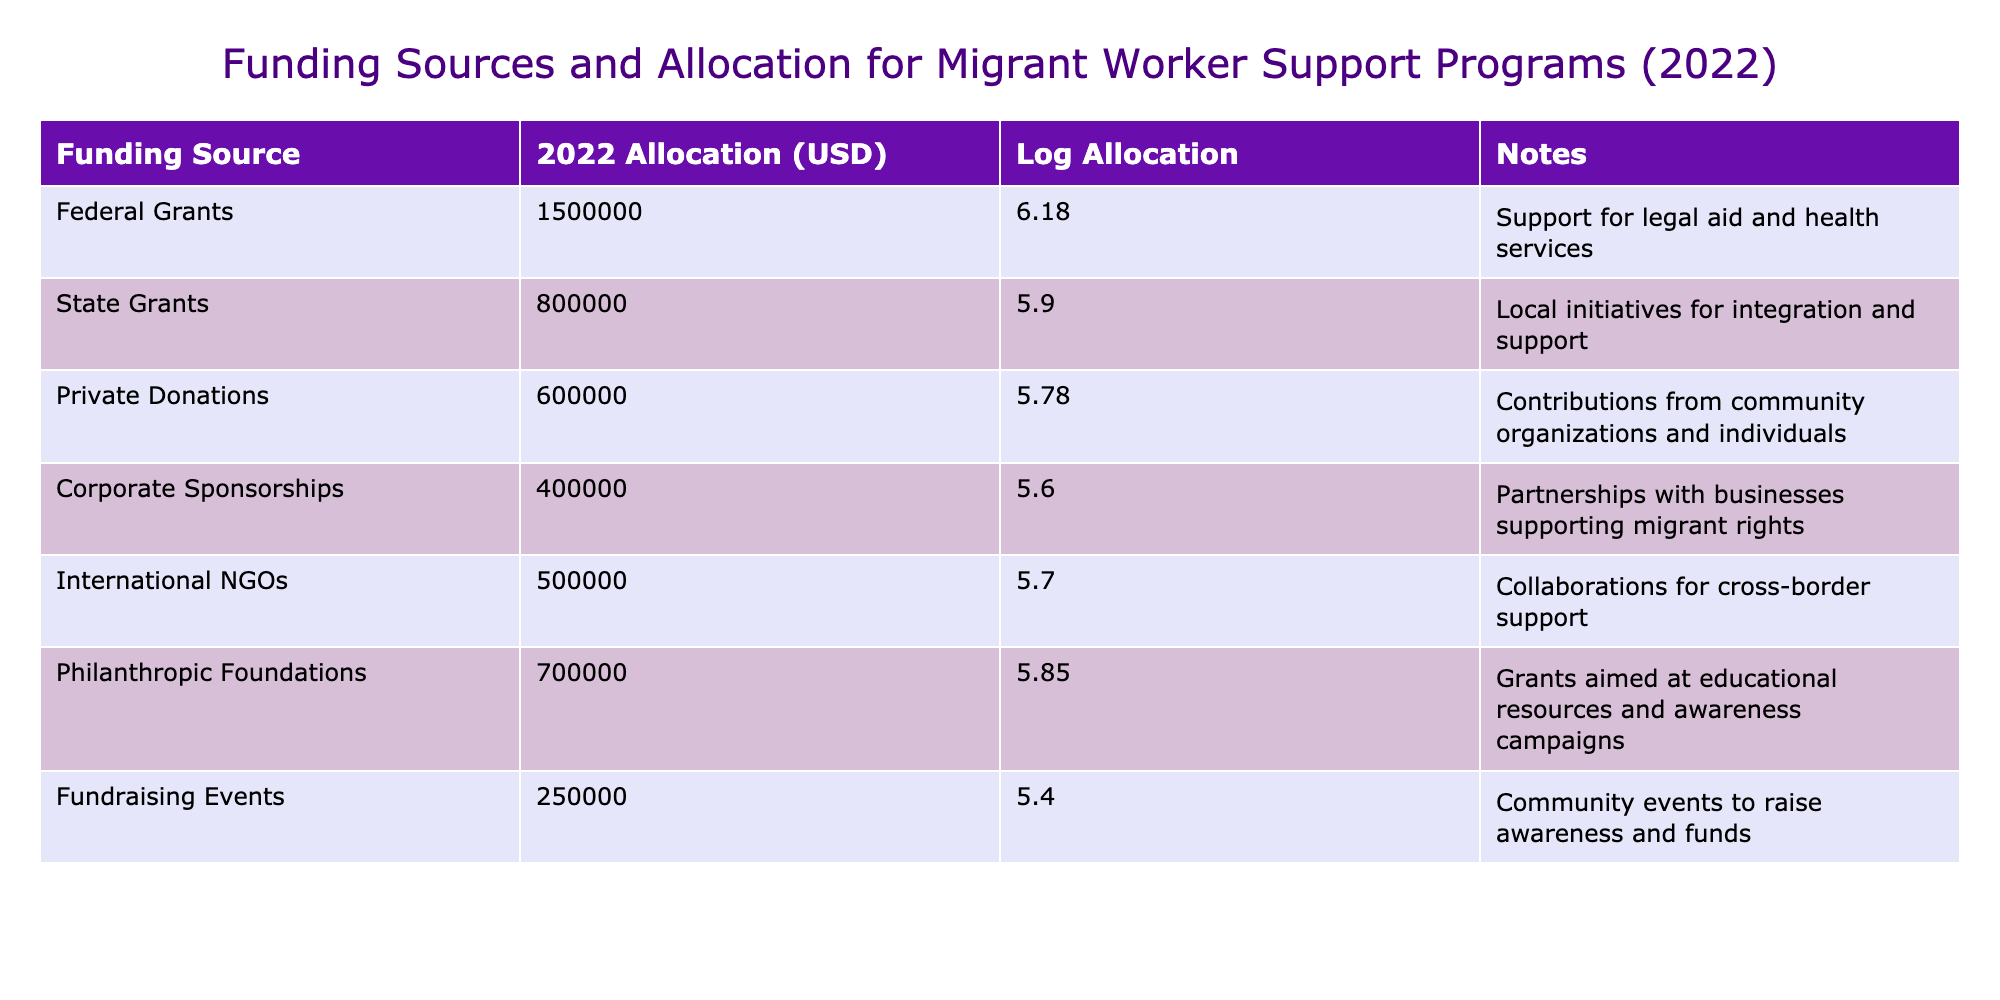What is the total allocation for Federal Grants and State Grants combined? The allocation for Federal Grants is 1,500,000 USD, and for State Grants, it is 800,000 USD. To find the total, you sum these two values: 1,500,000 + 800,000 = 2,300,000 USD.
Answer: 2,300,000 USD Which funding source has the lowest allocation amount? By examining the allocation amounts listed, the lowest amount is found under Fundraising Events, which has an allocation of 250,000 USD.
Answer: Fundraising Events Is the total allocation from Private Donations and Corporate Sponsorships greater than 1 million USD? The allocation for Private Donations is 600,000 USD and for Corporate Sponsorships is 400,000 USD. Adding these together gives 600,000 + 400,000 = 1,000,000 USD, which is not greater than 1 million.
Answer: No What is the average allocation across all funding sources? There are 7 funding sources. The total allocation is calculated as follows: 1,500,000 + 800,000 + 600,000 + 400,000 + 500,000 + 700,000 + 250,000 = 4,750,000 USD. The average is 4,750,000 / 7 = 678,571.43 USD.
Answer: 678,571.43 USD Is there a funding source that allocates exactly 500,000 USD? By checking the allocations, International NGOs has an allocation of exactly 500,000 USD.
Answer: Yes What is the difference in allocation between the highest and lowest funding sources? The highest allocation is for Federal Grants at 1,500,000 USD, and the lowest is for Fundraising Events at 250,000 USD. The difference is calculated as 1,500,000 - 250,000 = 1,250,000 USD.
Answer: 1,250,000 USD 